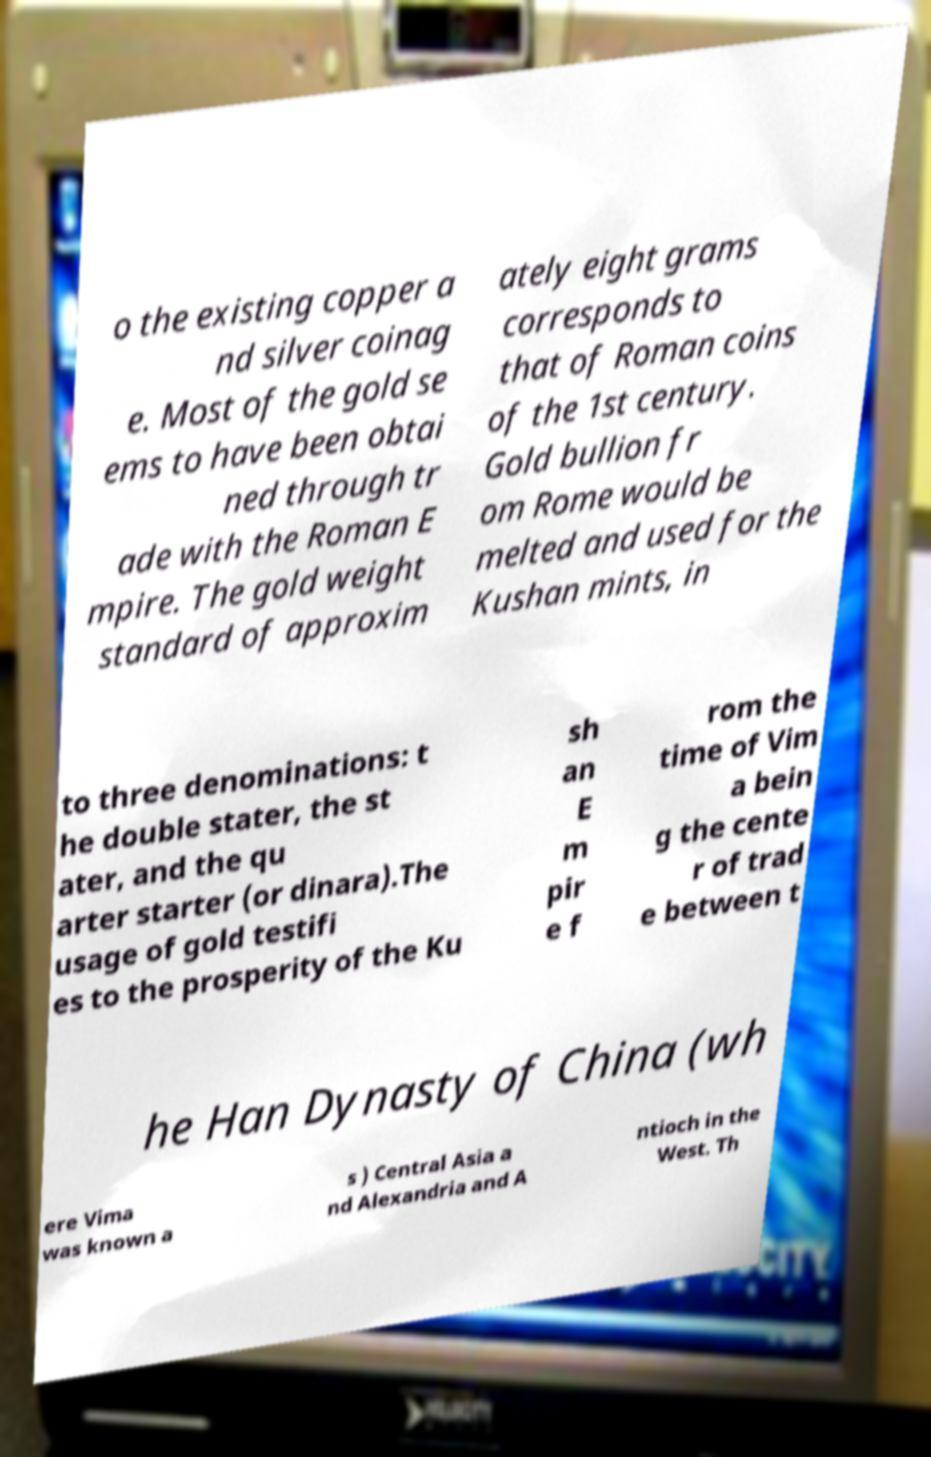There's text embedded in this image that I need extracted. Can you transcribe it verbatim? o the existing copper a nd silver coinag e. Most of the gold se ems to have been obtai ned through tr ade with the Roman E mpire. The gold weight standard of approxim ately eight grams corresponds to that of Roman coins of the 1st century. Gold bullion fr om Rome would be melted and used for the Kushan mints, in to three denominations: t he double stater, the st ater, and the qu arter starter (or dinara).The usage of gold testifi es to the prosperity of the Ku sh an E m pir e f rom the time of Vim a bein g the cente r of trad e between t he Han Dynasty of China (wh ere Vima was known a s ) Central Asia a nd Alexandria and A ntioch in the West. Th 